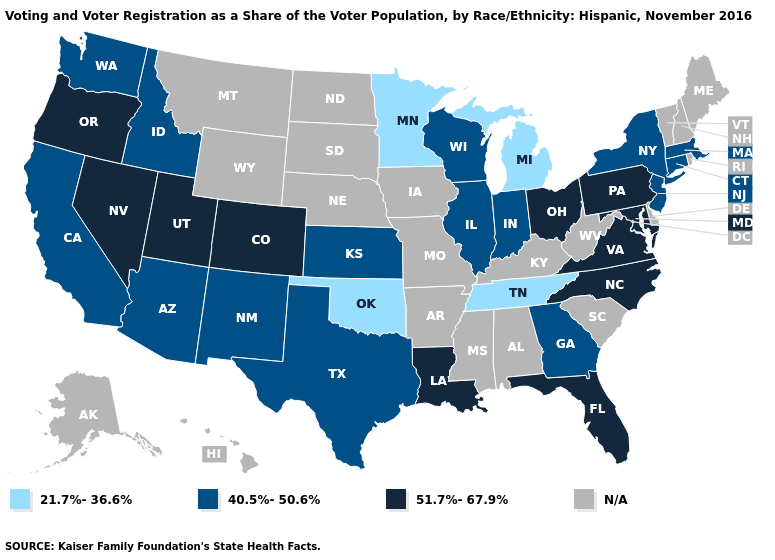What is the lowest value in states that border Virginia?
Quick response, please. 21.7%-36.6%. Among the states that border Nebraska , which have the highest value?
Be succinct. Colorado. Name the states that have a value in the range 51.7%-67.9%?
Answer briefly. Colorado, Florida, Louisiana, Maryland, Nevada, North Carolina, Ohio, Oregon, Pennsylvania, Utah, Virginia. What is the value of Texas?
Give a very brief answer. 40.5%-50.6%. What is the highest value in states that border Delaware?
Quick response, please. 51.7%-67.9%. Name the states that have a value in the range N/A?
Concise answer only. Alabama, Alaska, Arkansas, Delaware, Hawaii, Iowa, Kentucky, Maine, Mississippi, Missouri, Montana, Nebraska, New Hampshire, North Dakota, Rhode Island, South Carolina, South Dakota, Vermont, West Virginia, Wyoming. Among the states that border North Dakota , which have the lowest value?
Short answer required. Minnesota. Name the states that have a value in the range 21.7%-36.6%?
Keep it brief. Michigan, Minnesota, Oklahoma, Tennessee. What is the lowest value in the Northeast?
Keep it brief. 40.5%-50.6%. What is the lowest value in the West?
Short answer required. 40.5%-50.6%. What is the value of Hawaii?
Keep it brief. N/A. 